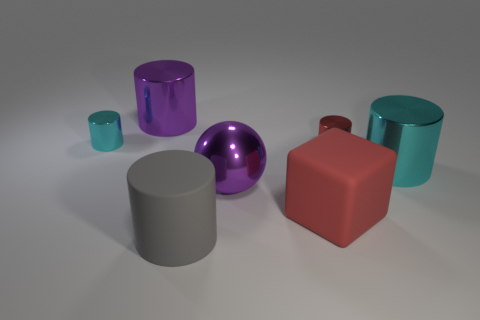Subtract all blue cylinders. Subtract all gray blocks. How many cylinders are left? 5 Add 3 purple metal cylinders. How many objects exist? 10 Subtract all cylinders. How many objects are left? 2 Subtract 1 gray cylinders. How many objects are left? 6 Subtract all big objects. Subtract all big gray rubber spheres. How many objects are left? 2 Add 5 big cylinders. How many big cylinders are left? 8 Add 1 big red things. How many big red things exist? 2 